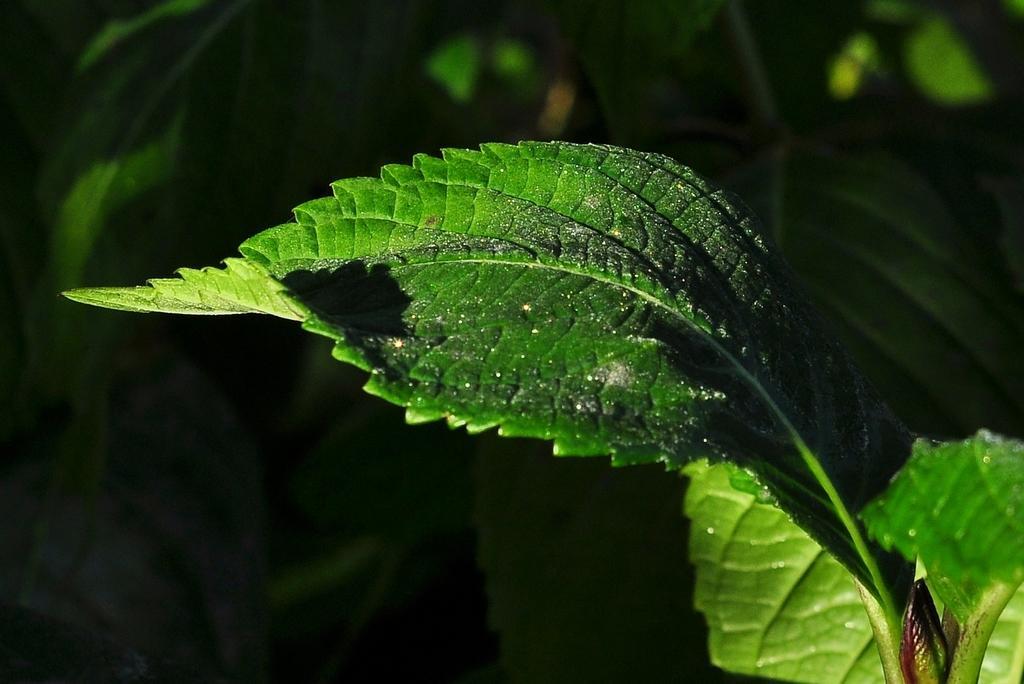Could you give a brief overview of what you see in this image? In this image we can see a leaf. In the background of the image there are leaves. 